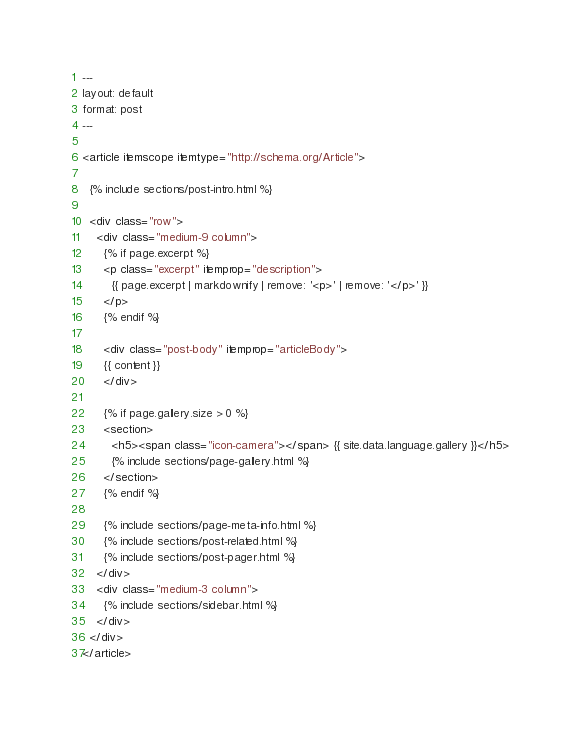Convert code to text. <code><loc_0><loc_0><loc_500><loc_500><_HTML_>---
layout: default
format: post
---

<article itemscope itemtype="http://schema.org/Article">

  {% include sections/post-intro.html %}

  <div class="row">
    <div class="medium-9 column">
      {% if page.excerpt %}
      <p class="excerpt" itemprop="description">
        {{ page.excerpt | markdownify | remove: '<p>' | remove: '</p>' }}
      </p>
      {% endif %}

      <div class="post-body" itemprop="articleBody">
      {{ content }}
      </div>

      {% if page.gallery.size > 0 %}
      <section>
        <h5><span class="icon-camera"></span> {{ site.data.language.gallery }}</h5>
        {% include sections/page-gallery.html %}
      </section>
      {% endif %}

      {% include sections/page-meta-info.html %}
      {% include sections/post-related.html %}
      {% include sections/post-pager.html %}
    </div>
    <div class="medium-3 column">
      {% include sections/sidebar.html %}
    </div>
  </div>
</article>
</code> 